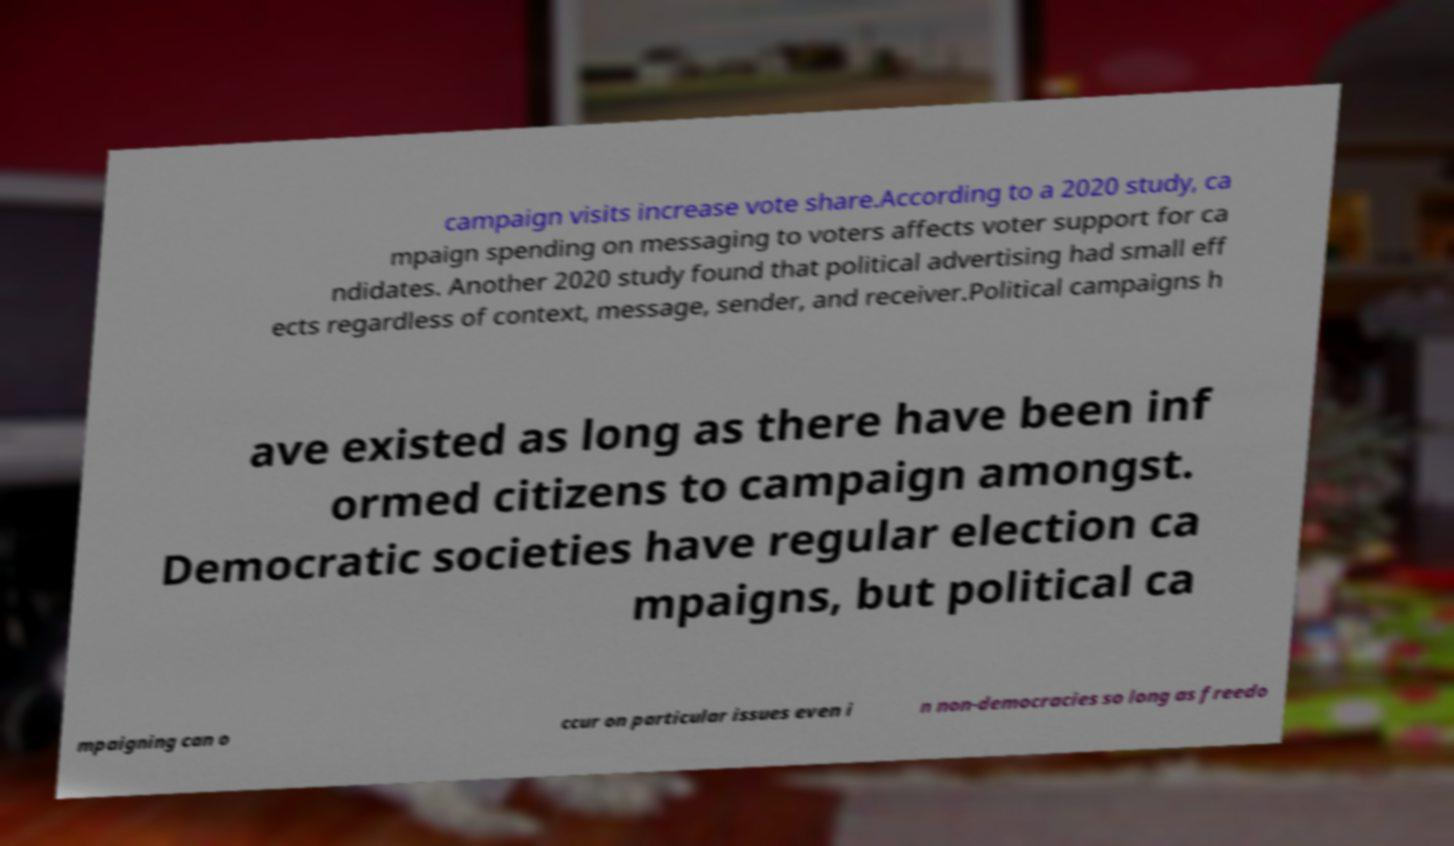Please identify and transcribe the text found in this image. campaign visits increase vote share.According to a 2020 study, ca mpaign spending on messaging to voters affects voter support for ca ndidates. Another 2020 study found that political advertising had small eff ects regardless of context, message, sender, and receiver.Political campaigns h ave existed as long as there have been inf ormed citizens to campaign amongst. Democratic societies have regular election ca mpaigns, but political ca mpaigning can o ccur on particular issues even i n non-democracies so long as freedo 